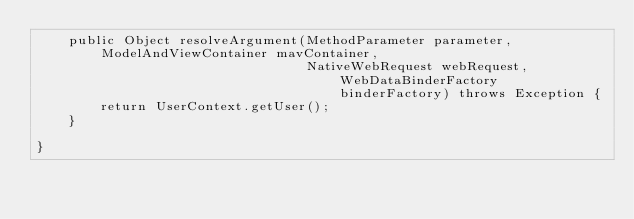<code> <loc_0><loc_0><loc_500><loc_500><_Java_>    public Object resolveArgument(MethodParameter parameter, ModelAndViewContainer mavContainer,
                                  NativeWebRequest webRequest, WebDataBinderFactory binderFactory) throws Exception {
        return UserContext.getUser();
    }

}
</code> 